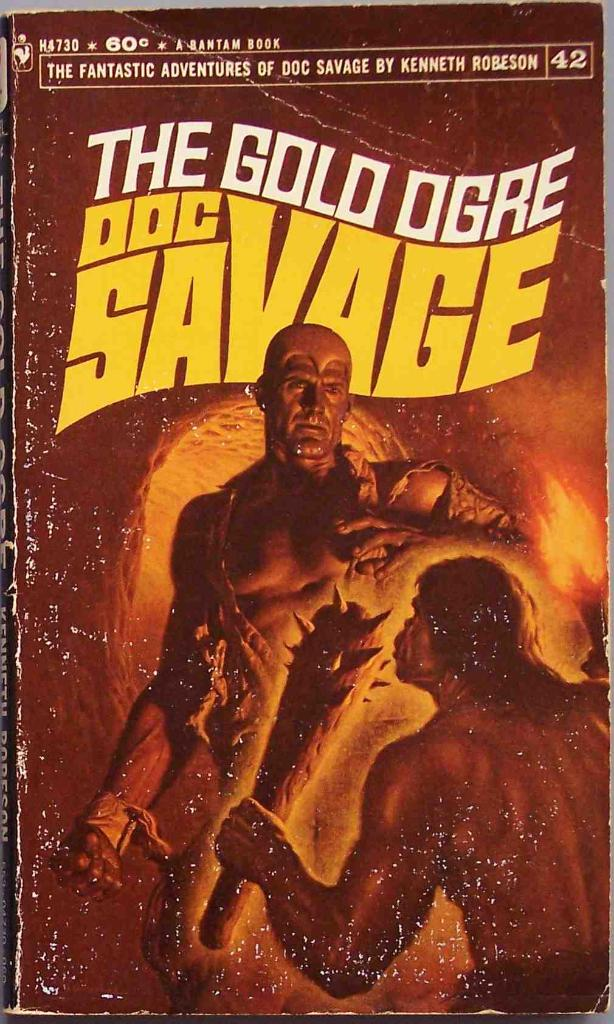Describe the thematic significance of the scene depicted on the cover. The cover art depicts a scene of confrontation between Doc Savage and a towering ogre, symbolizing the classic battle between good and evil, a prevalent theme in pulp fiction and adventure narratives. Doc Savage's posture and determined expression suggest bravery and resilience, traits typical of a hero. The ominous setting inside a cave with stalactites and limited light sources enhances the perilous situation, underlining themes of courage and heroism in the face of daunting adversaries. This visual metaphor not only captures the essence of the narrative but also serves to engage the viewer's imagination about the story's adventurous elements. 